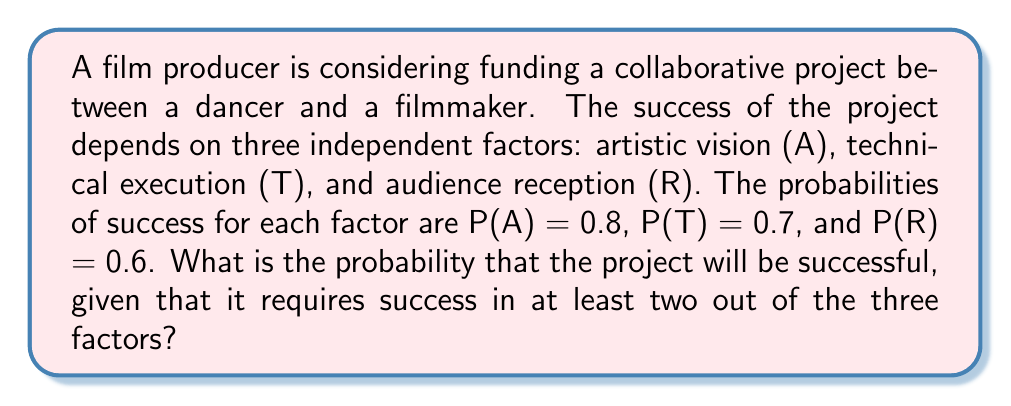Provide a solution to this math problem. Let's approach this step-by-step:

1) First, we need to calculate the probability of success for each possible combination of two or more factors:

   P(A and T and R) = 0.8 * 0.7 * 0.6 = 0.336
   P(A and T, not R) = 0.8 * 0.7 * (1-0.6) = 0.224
   P(A and R, not T) = 0.8 * (1-0.7) * 0.6 = 0.144
   P(T and R, not A) = (1-0.8) * 0.7 * 0.6 = 0.084

2) The total probability of success is the sum of these probabilities:

   P(success) = P(A and T and R) + P(A and T, not R) + P(A and R, not T) + P(T and R, not A)

3) Let's sum these probabilities:

   P(success) = 0.336 + 0.224 + 0.144 + 0.084 = 0.788

4) We can verify this result using the complement method:

   P(failure) = P(at most one factor succeeds)
              = P(no factors succeed) + P(exactly one factor succeeds)
              = (1-0.8)(1-0.7)(1-0.6) + 0.8(1-0.7)(1-0.6) + (1-0.8)0.7(1-0.6) + (1-0.8)(1-0.7)0.6
              = 0.024 + 0.096 + 0.056 + 0.036
              = 0.212

   P(success) = 1 - P(failure) = 1 - 0.212 = 0.788

Therefore, the probability of the project being successful is 0.788 or 78.8%.
Answer: 0.788 